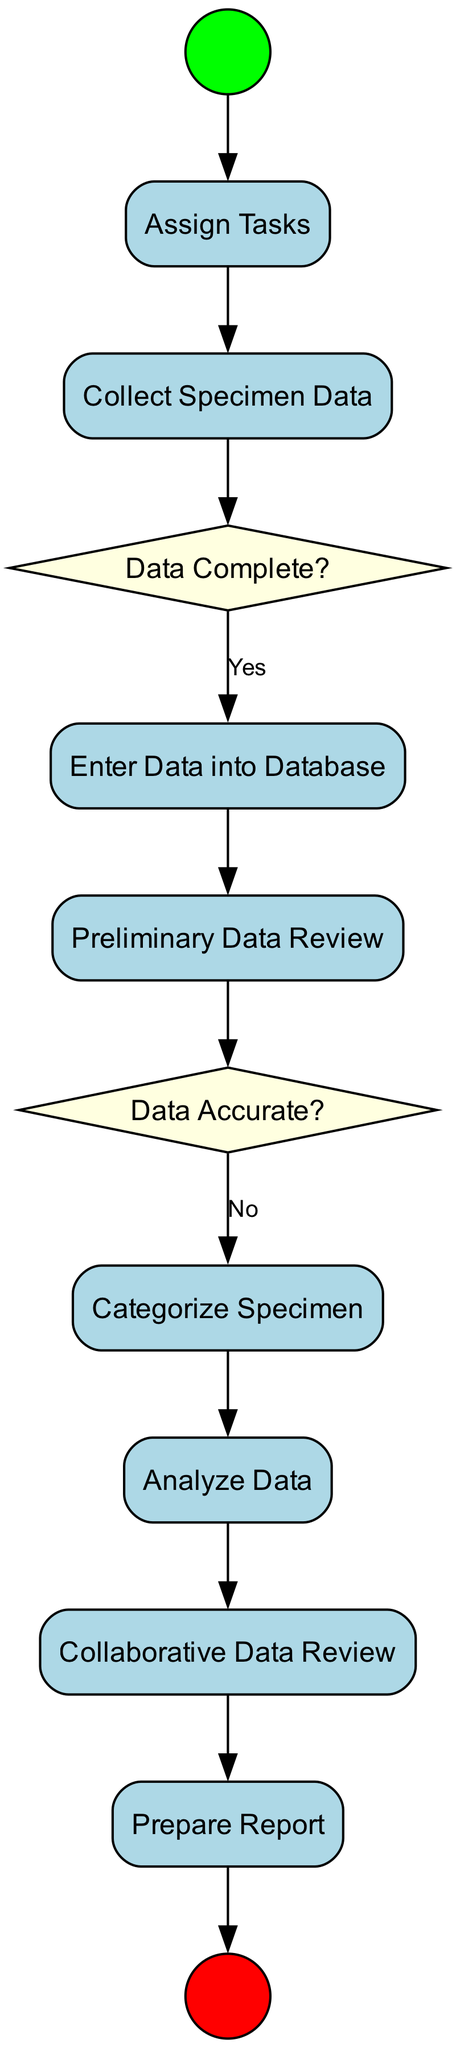What is the first activity in the diagram? The diagram begins with the 'Begin Data Collection' node, which indicates the initiation of the data collection process.
Answer: Begin Data Collection How many decision points are in the diagram? There are two decision points: 'Data Complete?' and 'Data Accurate?'. This can be counted by identifying nodes shaped as diamonds.
Answer: 2 What is the last activity before the end event? The last activity before reaching the end event is 'Prepare Report', which summarises the data collection and analysis findings.
Answer: Prepare Report What happens if the data is not complete? If the data is not complete, the process would loop back, indicated by the 'No' edge from 'Data Complete?' to the 'Collect Specimen Data' activity.
Answer: Collect Specimen Data What activity follows after the 'Preliminary Data Review'? After the 'Preliminary Data Review', the next activity is 'Data Accurate?', which serves as a verification step for the accuracy of the collected data.
Answer: Data Accurate? What are the two categories of nodes in the diagram? The two categories of nodes are 'Activities' (rectangles) and 'Decisions' (diamonds). Activities are the steps taken, while decisions are the points at which choices are made based on conditions.
Answer: Activities and Decisions How many edges are outgoing from the 'Enter Data into Database' node? There is one outgoing edge from the 'Enter Data into Database' node, leading to the 'Preliminary Data Review'. This can be seen by counting the connections from that node.
Answer: 1 What type of node is 'Categorize Specimen'? 'Categorize Specimen' is an Activity node, as indicated by its rectangular shape in the diagram intended to represent an action taken during the process.
Answer: Activity 